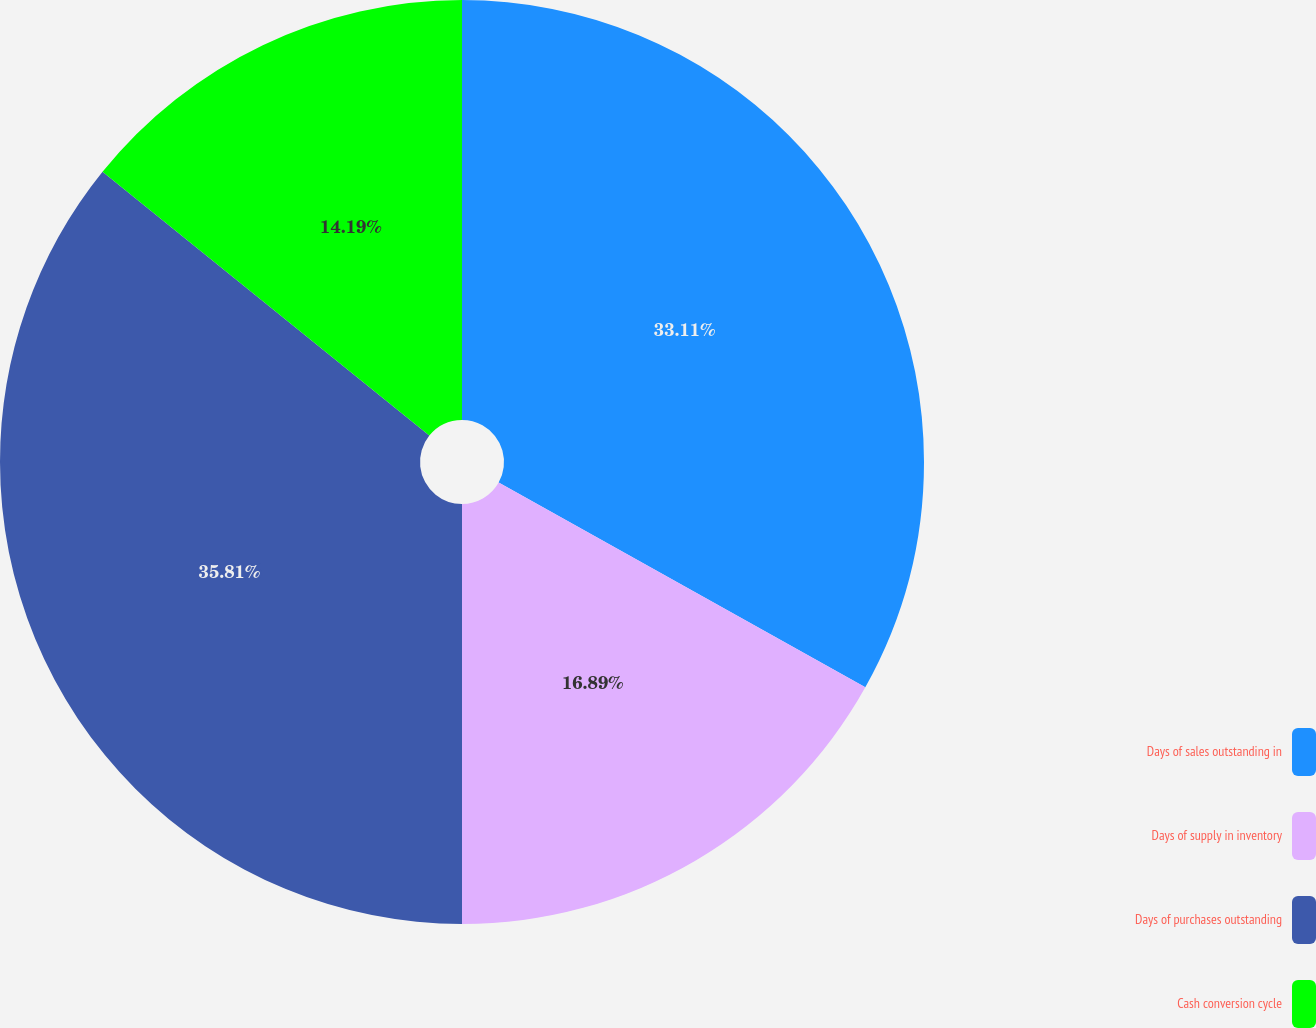Convert chart. <chart><loc_0><loc_0><loc_500><loc_500><pie_chart><fcel>Days of sales outstanding in<fcel>Days of supply in inventory<fcel>Days of purchases outstanding<fcel>Cash conversion cycle<nl><fcel>33.11%<fcel>16.89%<fcel>35.81%<fcel>14.19%<nl></chart> 